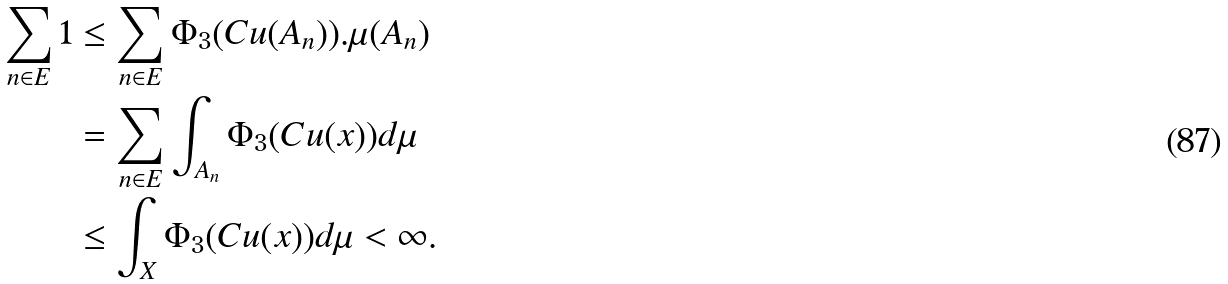<formula> <loc_0><loc_0><loc_500><loc_500>\sum _ { n \in E } 1 & \leq \sum _ { n \in E } \Phi _ { 3 } ( C u ( A _ { n } ) ) . \mu ( A _ { n } ) \\ & = \sum _ { n \in E } \int _ { A _ { n } } \Phi _ { 3 } ( C u ( x ) ) d \mu \\ & \leq \int _ { X } \Phi _ { 3 } ( C u ( x ) ) d \mu < \infty .</formula> 